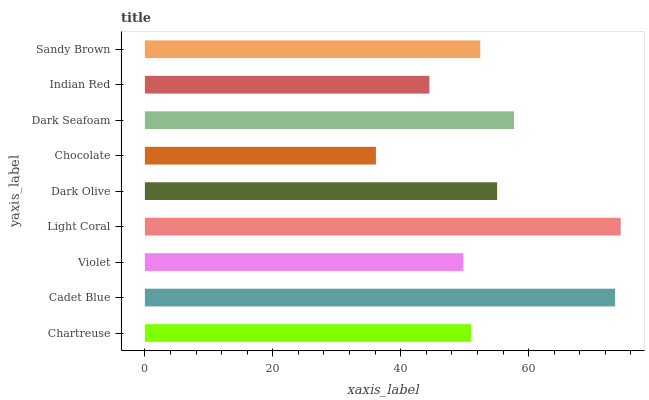Is Chocolate the minimum?
Answer yes or no. Yes. Is Light Coral the maximum?
Answer yes or no. Yes. Is Cadet Blue the minimum?
Answer yes or no. No. Is Cadet Blue the maximum?
Answer yes or no. No. Is Cadet Blue greater than Chartreuse?
Answer yes or no. Yes. Is Chartreuse less than Cadet Blue?
Answer yes or no. Yes. Is Chartreuse greater than Cadet Blue?
Answer yes or no. No. Is Cadet Blue less than Chartreuse?
Answer yes or no. No. Is Sandy Brown the high median?
Answer yes or no. Yes. Is Sandy Brown the low median?
Answer yes or no. Yes. Is Indian Red the high median?
Answer yes or no. No. Is Cadet Blue the low median?
Answer yes or no. No. 